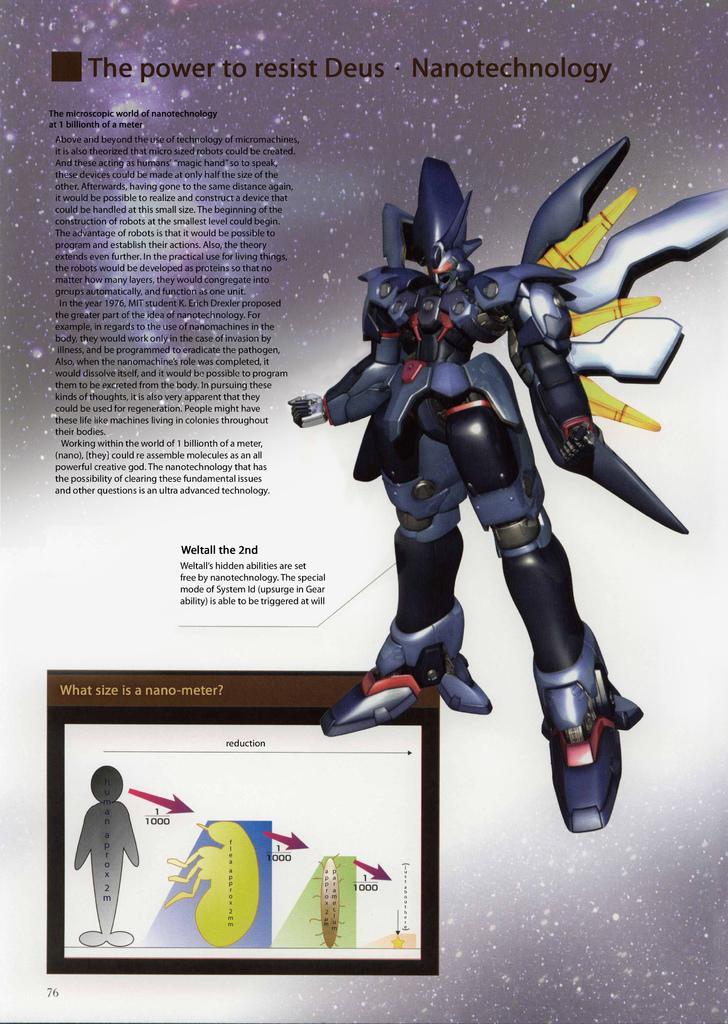Please provide a concise description of this image. In the picture I can see a toy on the right side. I can see the text on the left side. 